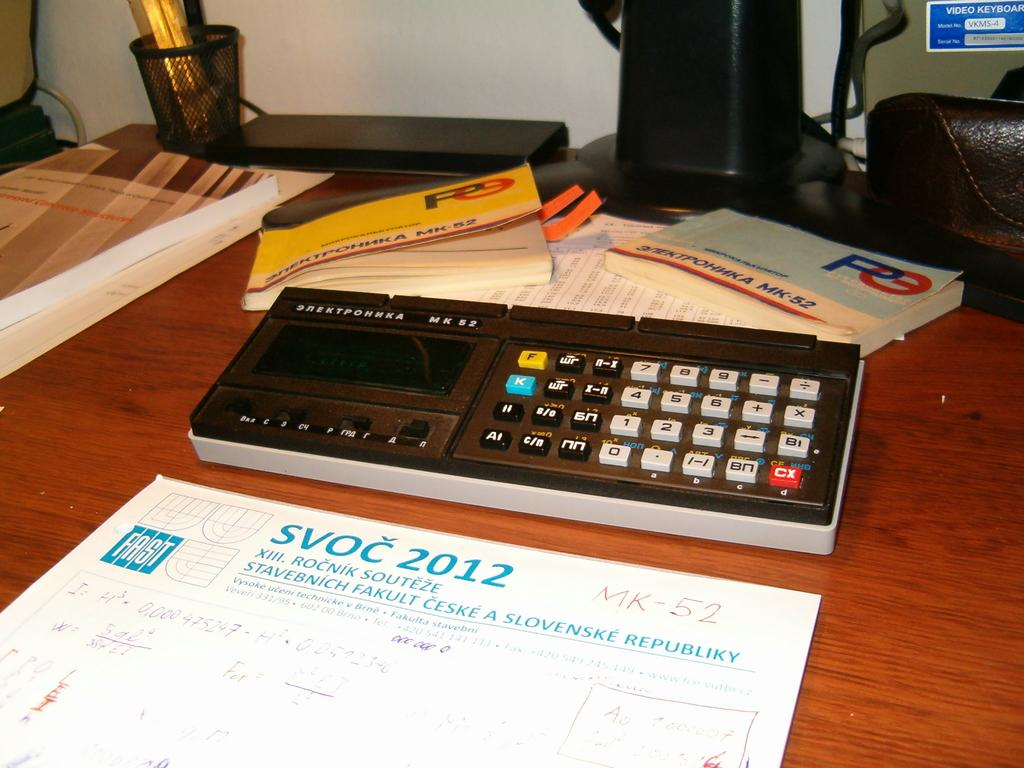<image>
Share a concise interpretation of the image provided. A desk with a calculator and some books about MK-52 and a notepad about Slovenske Republiky. 